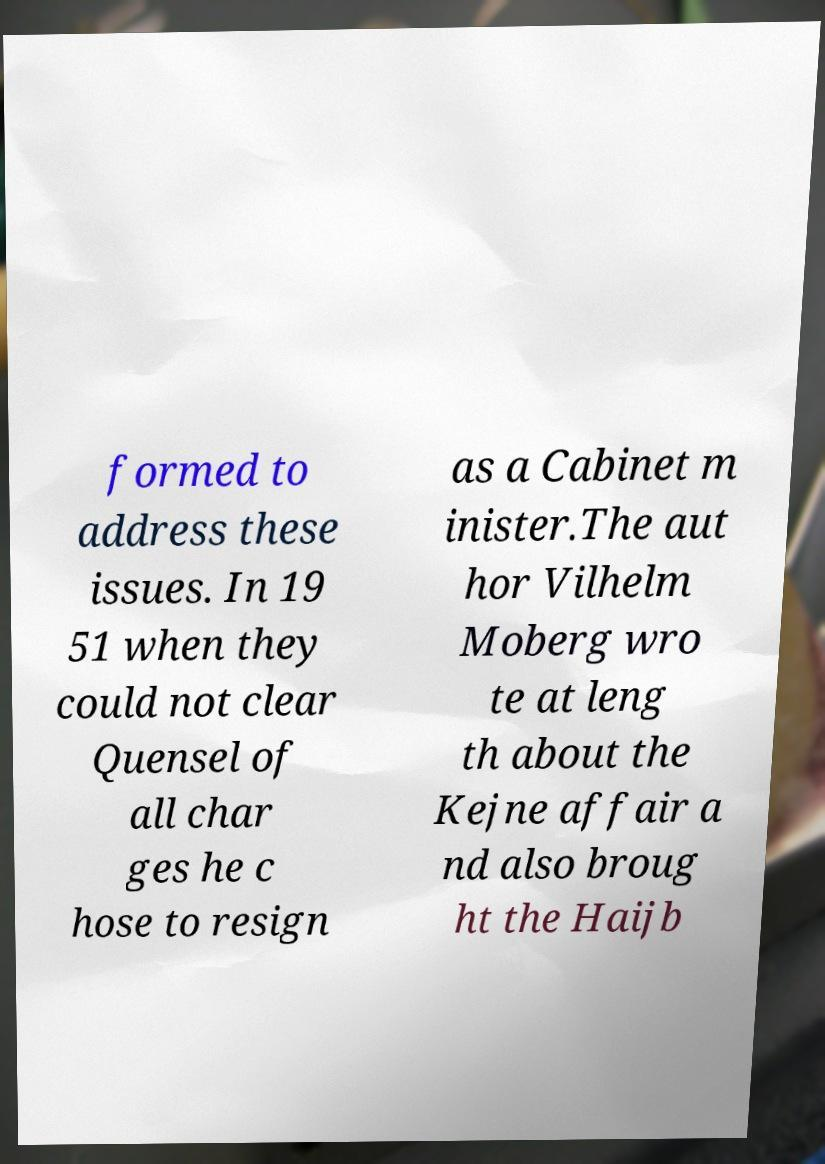Please identify and transcribe the text found in this image. formed to address these issues. In 19 51 when they could not clear Quensel of all char ges he c hose to resign as a Cabinet m inister.The aut hor Vilhelm Moberg wro te at leng th about the Kejne affair a nd also broug ht the Haijb 